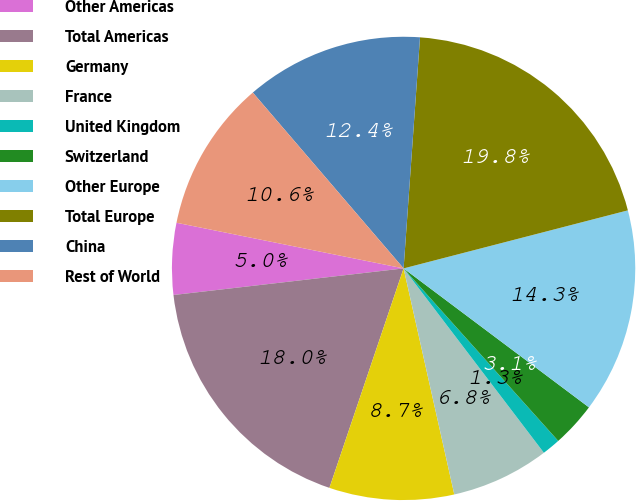Convert chart to OTSL. <chart><loc_0><loc_0><loc_500><loc_500><pie_chart><fcel>Other Americas<fcel>Total Americas<fcel>Germany<fcel>France<fcel>United Kingdom<fcel>Switzerland<fcel>Other Europe<fcel>Total Europe<fcel>China<fcel>Rest of World<nl><fcel>4.99%<fcel>17.98%<fcel>8.7%<fcel>6.84%<fcel>1.28%<fcel>3.13%<fcel>14.27%<fcel>19.84%<fcel>12.41%<fcel>10.56%<nl></chart> 